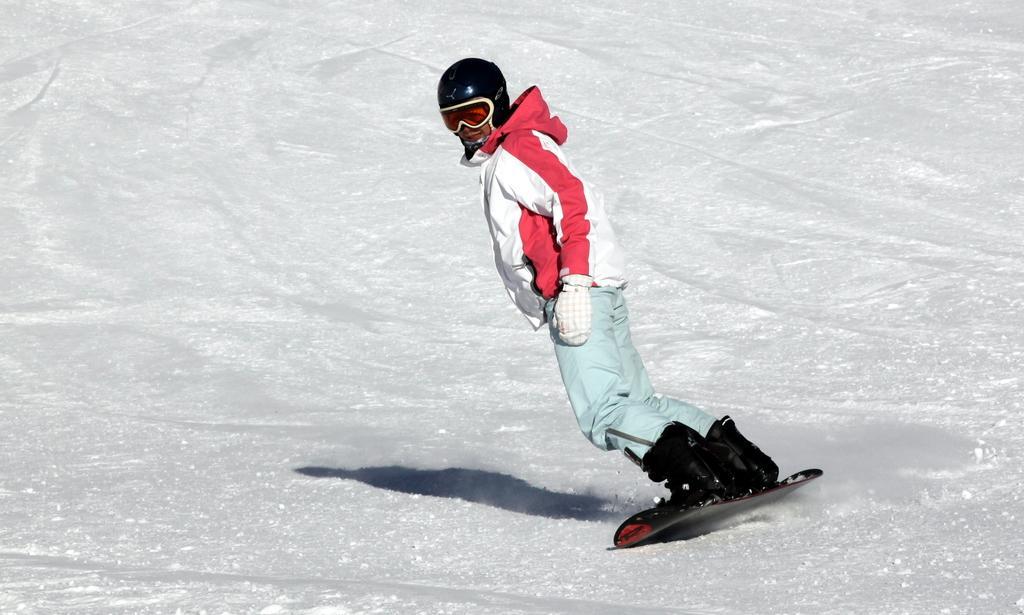Please provide a concise description of this image. In this picture I can see a person wearing a helmet, jacket, pants and shoes. I can see that the person is skiing on the snow. 